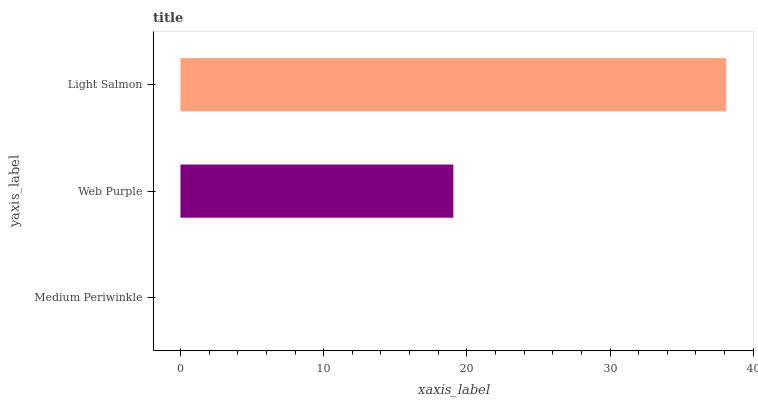Is Medium Periwinkle the minimum?
Answer yes or no. Yes. Is Light Salmon the maximum?
Answer yes or no. Yes. Is Web Purple the minimum?
Answer yes or no. No. Is Web Purple the maximum?
Answer yes or no. No. Is Web Purple greater than Medium Periwinkle?
Answer yes or no. Yes. Is Medium Periwinkle less than Web Purple?
Answer yes or no. Yes. Is Medium Periwinkle greater than Web Purple?
Answer yes or no. No. Is Web Purple less than Medium Periwinkle?
Answer yes or no. No. Is Web Purple the high median?
Answer yes or no. Yes. Is Web Purple the low median?
Answer yes or no. Yes. Is Light Salmon the high median?
Answer yes or no. No. Is Medium Periwinkle the low median?
Answer yes or no. No. 